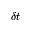<formula> <loc_0><loc_0><loc_500><loc_500>\delta t</formula> 